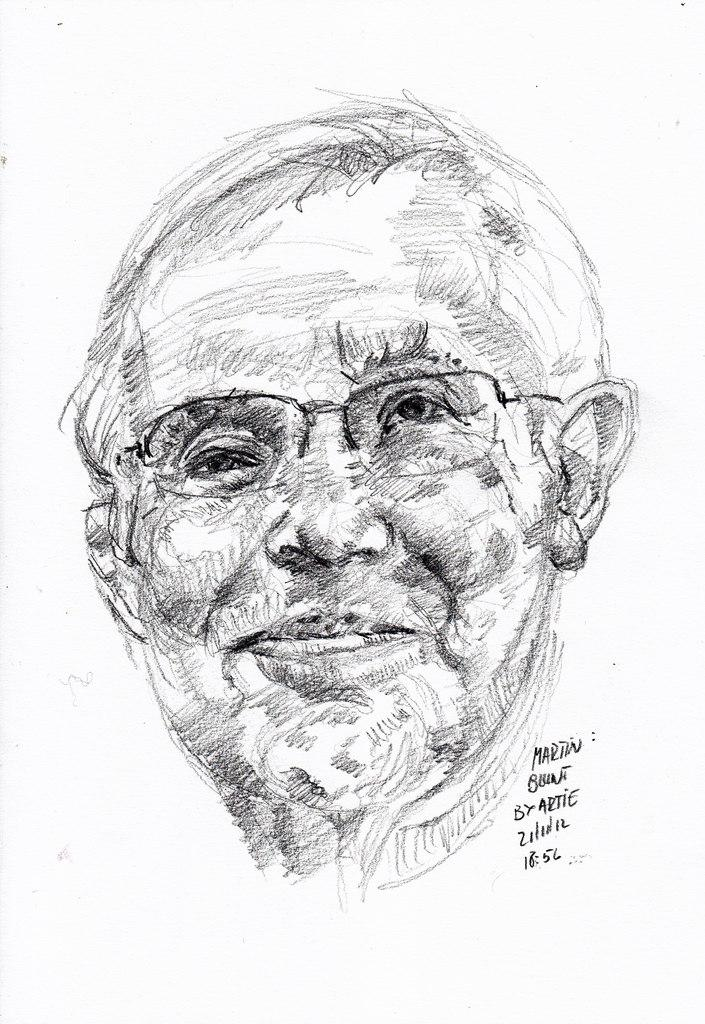What is the main subject of the image? There is a painting in the image. What does the painting depict? The painting depicts a person. Can you describe the person in the painting? The person in the painting is wearing spectacles. Are there any words on the painting? Yes, there are words written on the painting. What type of toothbrush is the person using in the painting? There is no toothbrush present in the painting; the person is depicted wearing spectacles. Is the painting made of marble? The facts provided do not mention the material of the painting, but there is no indication that it is made of marble. 